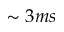Convert formula to latex. <formula><loc_0><loc_0><loc_500><loc_500>\sim 3 m s</formula> 